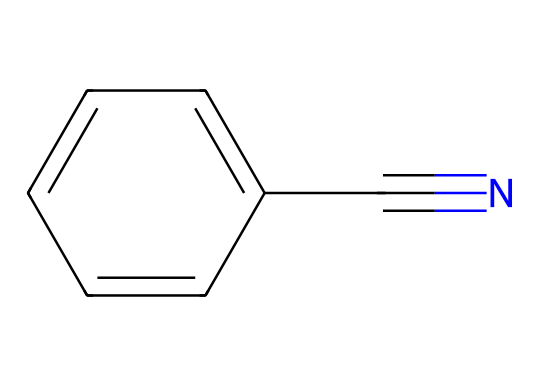What is the molecular formula of benzonitrile? The SMILES representation indicates that there are six carbon atoms in the benzene ring and one additional carbon from the nitrile group (C#N), along with one nitrogen atom. Therefore, the molecular formula can be deduced as C7H5N.
Answer: C7H5N How many carbon atoms are in the benzonitrile structure? The structure shows a benzene ring with six carbon atoms (c1ccccc1) and an additional carbon atom connected to the nitrile (C#N), giving a total of seven carbon atoms.
Answer: 7 What type of functional group is present in benzonitrile? The compound includes a nitrile functional group (C#N), indicated by the carbon triple-bonded to a nitrogen atom. This is characteristic of nitriles.
Answer: nitrile Does benzonitrile contain any oxygen atoms? Analyzing the SMILES structure reveals no presence of oxygen atoms, as all constituents are carbon and nitrogen.
Answer: no What is the hybridization of the carbon atom in the nitrile group? The carbon in the nitrile group is bonded through a triple bond to nitrogen, which means it is sp hybridized, with two sp hybridized orbitals forming a triple bond and one remaining for any additional connections.
Answer: sp What is the total number of nitrogen atoms in benzonitrile? From the structure, there is one nitrogen atom indicated by the nitrile part (C#N), which leads to the conclusion that benzonitrile contains a single nitrogen atom.
Answer: 1 